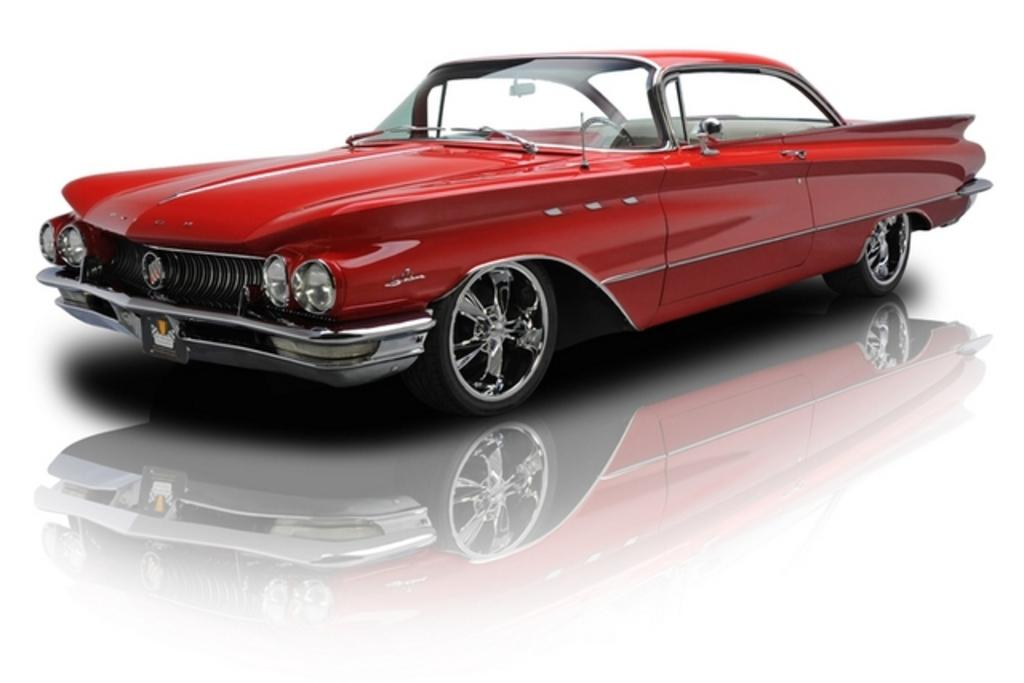What is the main subject of the image? The main subject of the image is a car. What is the car situated on? The car is on a white surface. What type of drug is the car using in the image? There is no drug present in the image, as it features a car on a white surface. 